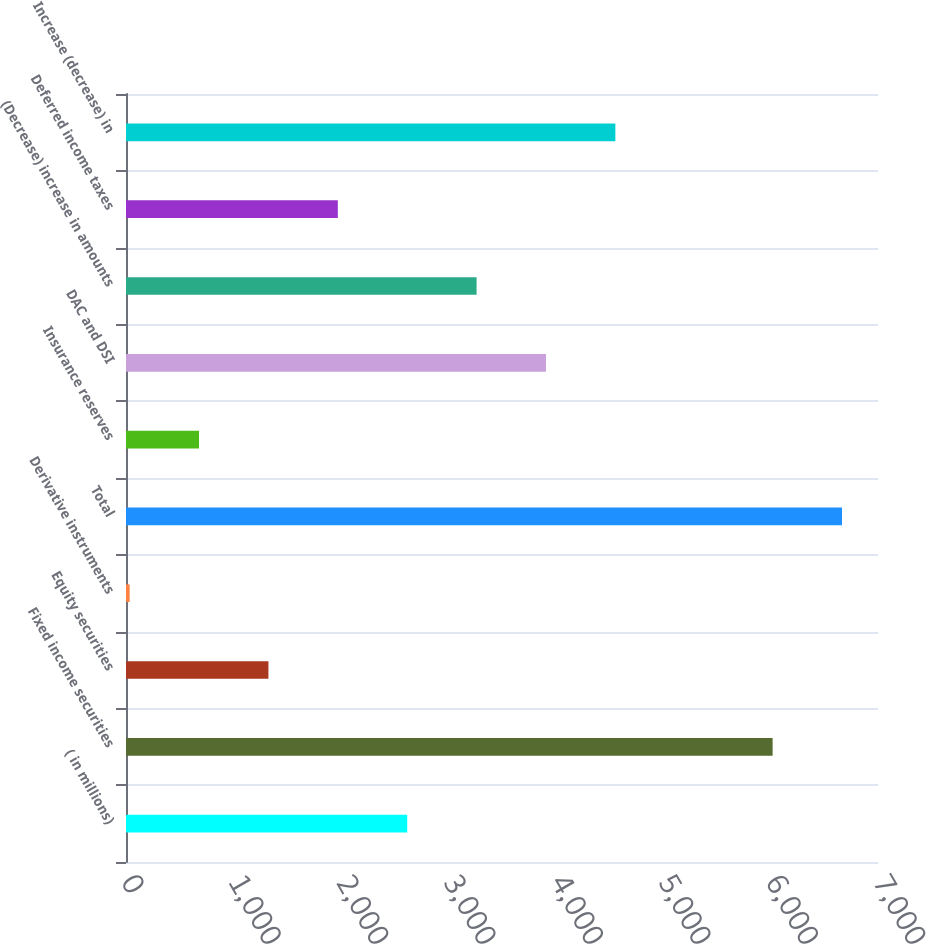<chart> <loc_0><loc_0><loc_500><loc_500><bar_chart><fcel>( in millions)<fcel>Fixed income securities<fcel>Equity securities<fcel>Derivative instruments<fcel>Total<fcel>Insurance reserves<fcel>DAC and DSI<fcel>(Decrease) increase in amounts<fcel>Deferred income taxes<fcel>Increase (decrease) in<nl><fcel>2617.6<fcel>6019<fcel>1325.8<fcel>34<fcel>6664.9<fcel>679.9<fcel>3909.4<fcel>3263.5<fcel>1971.7<fcel>4555.3<nl></chart> 